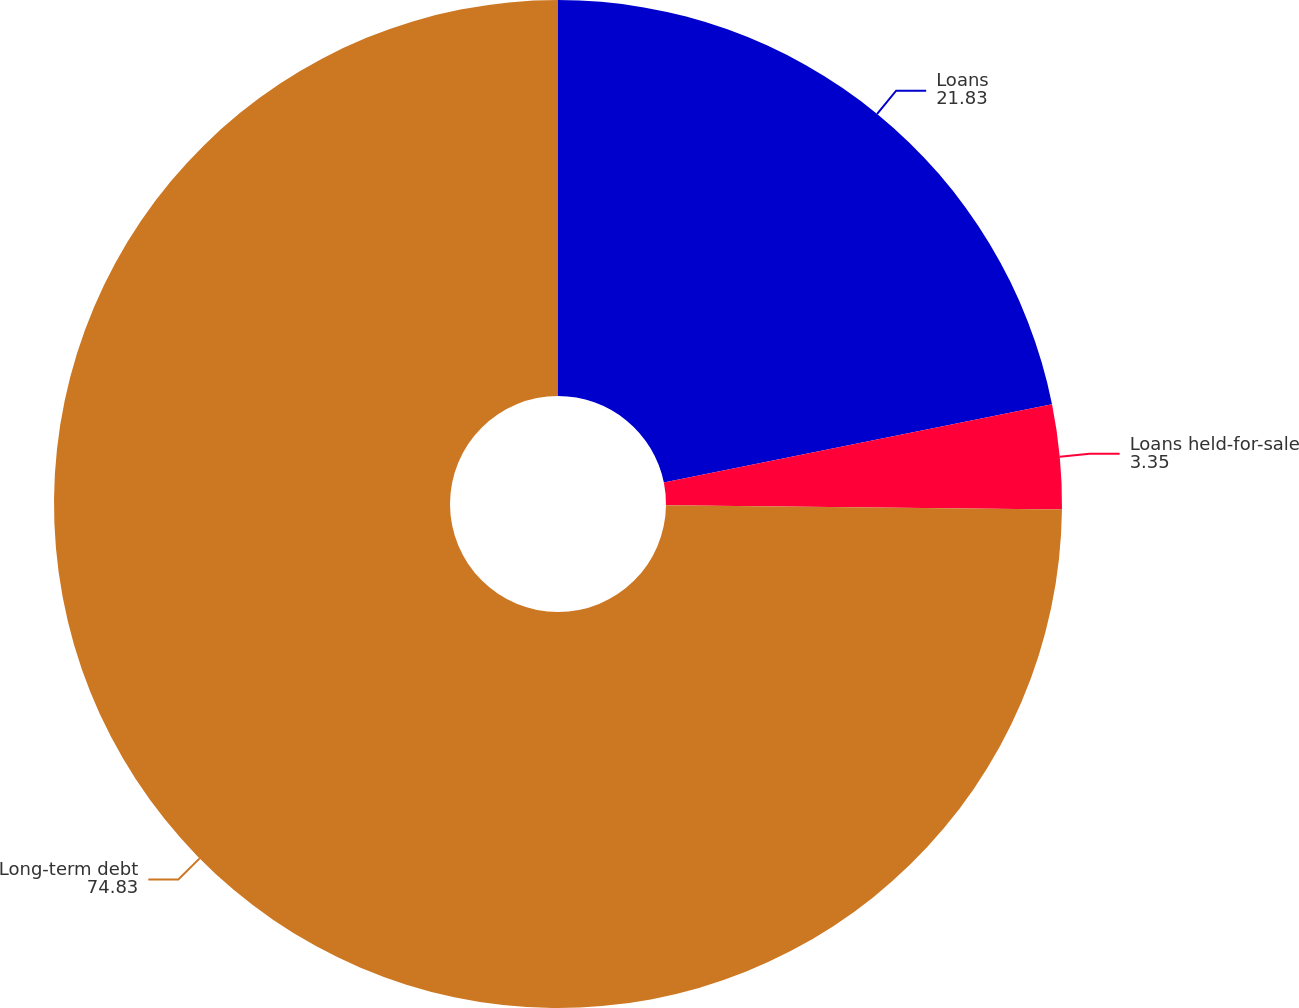<chart> <loc_0><loc_0><loc_500><loc_500><pie_chart><fcel>Loans<fcel>Loans held-for-sale<fcel>Long-term debt<nl><fcel>21.83%<fcel>3.35%<fcel>74.83%<nl></chart> 